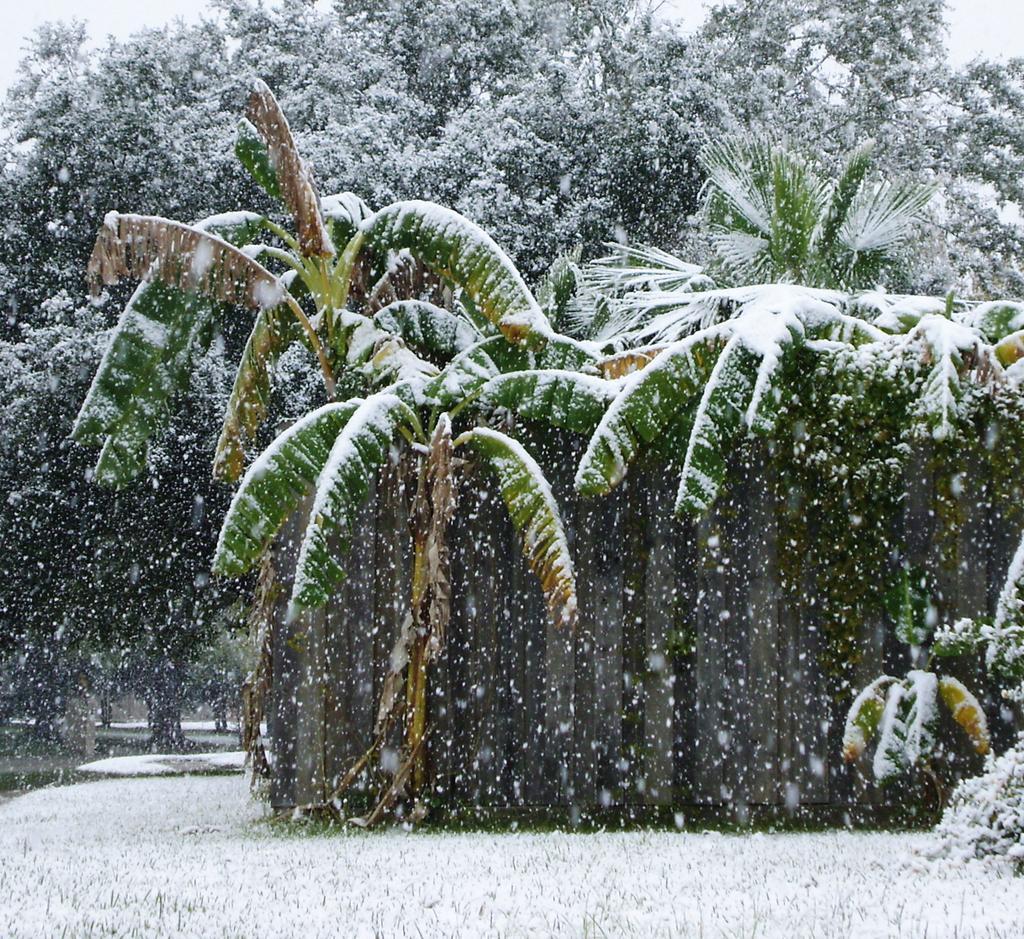Can you describe this image briefly? In this image there are trees. There is snow on the ground and on the trees. At the top there is the sky. 